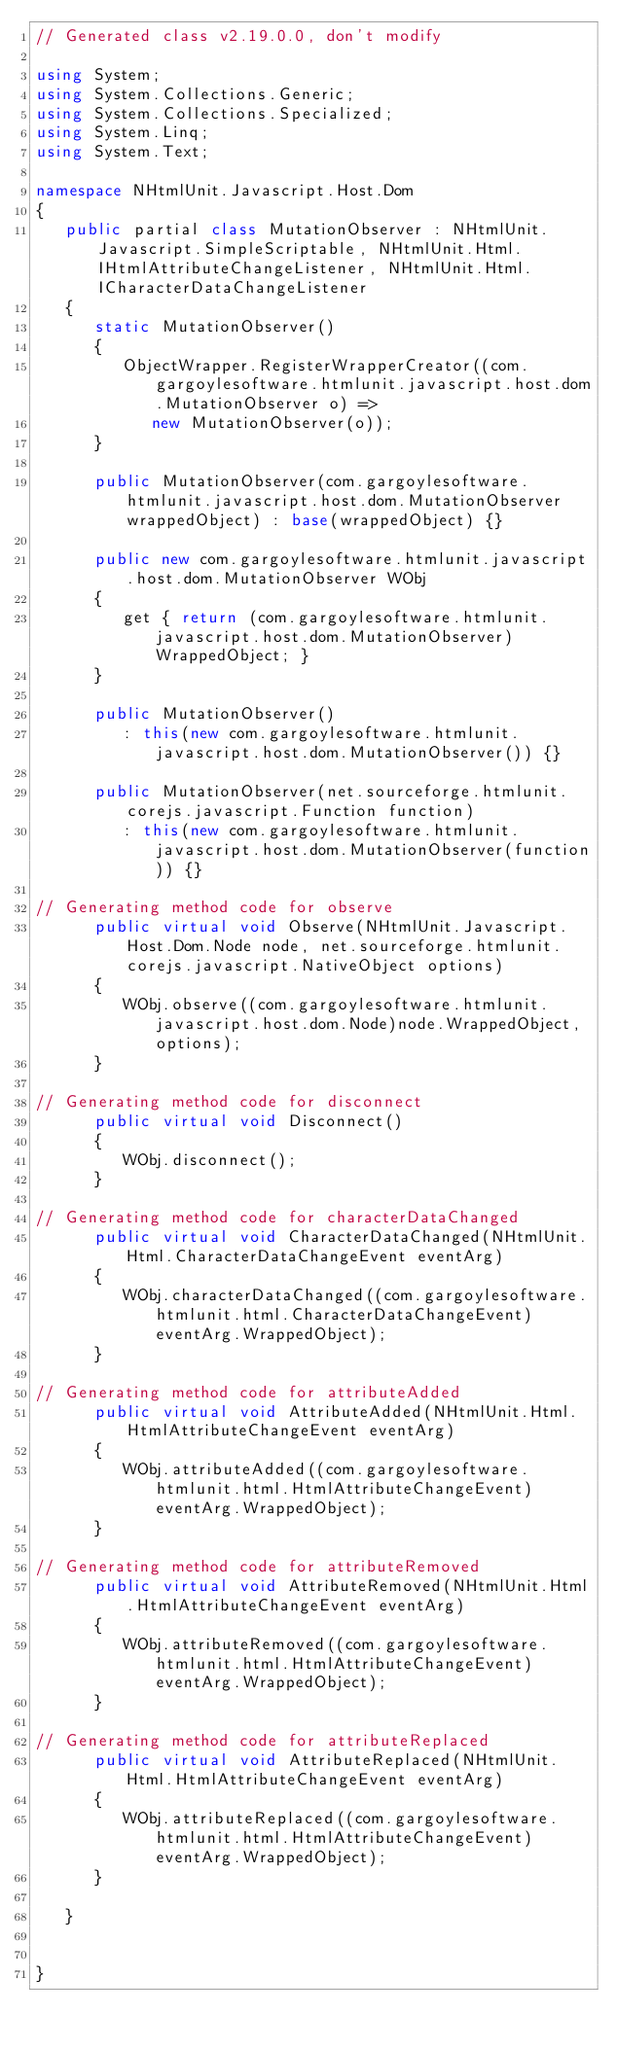Convert code to text. <code><loc_0><loc_0><loc_500><loc_500><_C#_>// Generated class v2.19.0.0, don't modify

using System;
using System.Collections.Generic;
using System.Collections.Specialized;
using System.Linq;
using System.Text;

namespace NHtmlUnit.Javascript.Host.Dom
{
   public partial class MutationObserver : NHtmlUnit.Javascript.SimpleScriptable, NHtmlUnit.Html.IHtmlAttributeChangeListener, NHtmlUnit.Html.ICharacterDataChangeListener
   {
      static MutationObserver()
      {
         ObjectWrapper.RegisterWrapperCreator((com.gargoylesoftware.htmlunit.javascript.host.dom.MutationObserver o) =>
            new MutationObserver(o));
      }

      public MutationObserver(com.gargoylesoftware.htmlunit.javascript.host.dom.MutationObserver wrappedObject) : base(wrappedObject) {}

      public new com.gargoylesoftware.htmlunit.javascript.host.dom.MutationObserver WObj
      {
         get { return (com.gargoylesoftware.htmlunit.javascript.host.dom.MutationObserver)WrappedObject; }
      }

      public MutationObserver()
         : this(new com.gargoylesoftware.htmlunit.javascript.host.dom.MutationObserver()) {}

      public MutationObserver(net.sourceforge.htmlunit.corejs.javascript.Function function)
         : this(new com.gargoylesoftware.htmlunit.javascript.host.dom.MutationObserver(function)) {}

// Generating method code for observe
      public virtual void Observe(NHtmlUnit.Javascript.Host.Dom.Node node, net.sourceforge.htmlunit.corejs.javascript.NativeObject options)
      {
         WObj.observe((com.gargoylesoftware.htmlunit.javascript.host.dom.Node)node.WrappedObject, options);
      }

// Generating method code for disconnect
      public virtual void Disconnect()
      {
         WObj.disconnect();
      }

// Generating method code for characterDataChanged
      public virtual void CharacterDataChanged(NHtmlUnit.Html.CharacterDataChangeEvent eventArg)
      {
         WObj.characterDataChanged((com.gargoylesoftware.htmlunit.html.CharacterDataChangeEvent)eventArg.WrappedObject);
      }

// Generating method code for attributeAdded
      public virtual void AttributeAdded(NHtmlUnit.Html.HtmlAttributeChangeEvent eventArg)
      {
         WObj.attributeAdded((com.gargoylesoftware.htmlunit.html.HtmlAttributeChangeEvent)eventArg.WrappedObject);
      }

// Generating method code for attributeRemoved
      public virtual void AttributeRemoved(NHtmlUnit.Html.HtmlAttributeChangeEvent eventArg)
      {
         WObj.attributeRemoved((com.gargoylesoftware.htmlunit.html.HtmlAttributeChangeEvent)eventArg.WrappedObject);
      }

// Generating method code for attributeReplaced
      public virtual void AttributeReplaced(NHtmlUnit.Html.HtmlAttributeChangeEvent eventArg)
      {
         WObj.attributeReplaced((com.gargoylesoftware.htmlunit.html.HtmlAttributeChangeEvent)eventArg.WrappedObject);
      }

   }


}
</code> 